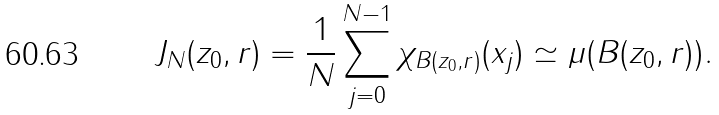Convert formula to latex. <formula><loc_0><loc_0><loc_500><loc_500>J _ { N } ( z _ { 0 } , r ) = \frac { 1 } { N } \sum _ { j = 0 } ^ { N - 1 } \chi _ { B ( z _ { 0 } , r ) } ( x _ { j } ) \simeq \mu ( B ( z _ { 0 } , r ) ) .</formula> 